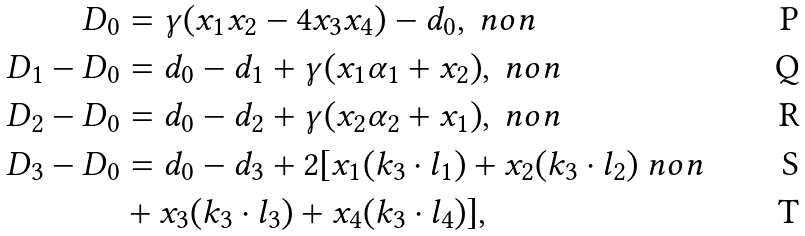Convert formula to latex. <formula><loc_0><loc_0><loc_500><loc_500>D _ { 0 } & = \gamma ( x _ { 1 } x _ { 2 } - 4 x _ { 3 } x _ { 4 } ) - d _ { 0 } , \ n o n \\ D _ { 1 } - D _ { 0 } & = d _ { 0 } - d _ { 1 } + \gamma ( x _ { 1 } \alpha _ { 1 } + x _ { 2 } ) , \ n o n \\ D _ { 2 } - D _ { 0 } & = d _ { 0 } - d _ { 2 } + \gamma ( x _ { 2 } \alpha _ { 2 } + x _ { 1 } ) , \ n o n \\ D _ { 3 } - D _ { 0 } & = d _ { 0 } - d _ { 3 } + 2 [ x _ { 1 } ( k _ { 3 } \cdot l _ { 1 } ) + x _ { 2 } ( k _ { 3 } \cdot l _ { 2 } ) \ n o n \\ & + x _ { 3 } ( k _ { 3 } \cdot l _ { 3 } ) + x _ { 4 } ( k _ { 3 } \cdot l _ { 4 } ) ] ,</formula> 